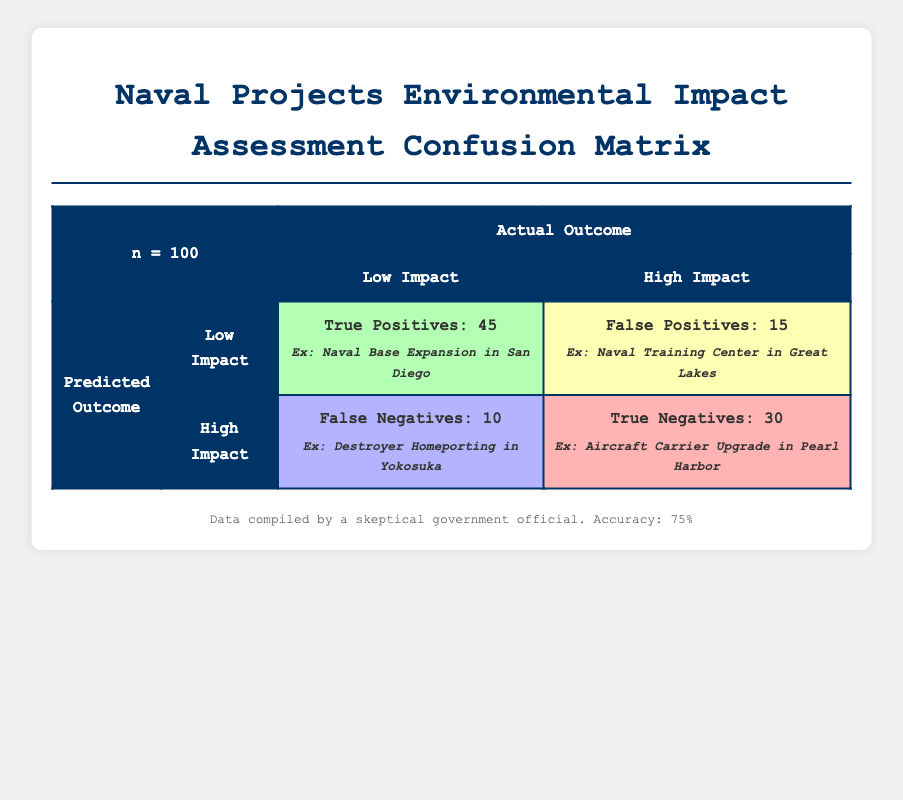What are the total True Positives reported in the assessment? The table indicates that there are 45 True Positives, which represents the projects correctly assessed as having low environmental impact that also truly have a low environmental impact.
Answer: 45 How many assessments inaccurately reported a low environmental impact? The False Positives count is 15, indicating these assessments claimed low environmental impact when the actual impact was high.
Answer: 15 What is the total number of assessments classified as High Environmental Impact? To find the total High Environmental Impact assessments, we add True Negatives (30) and False Negatives (10), giving 30 + 10 = 40.
Answer: 40 What percentage of the assessments were True Positives? To find the percentage, divide the number of True Positives (45) by the total assessments (100) and multiply by 100: (45/100) * 100 = 45%.
Answer: 45% Is it true that more assessments accurately reported Low Environmental Impact than those inaccurately reported as High Environmental Impact? Yes, there are 45 True Positives compared to 10 False Negatives. Thus, the accurate reports exceed the inaccurate ones.
Answer: Yes How many assessments had a correct High Environmental Impact prediction? There are 30 True Negatives, indicating these assessments correctly identified projects as having high environmental impact.
Answer: 30 What is the sum of all Negative assessments? The sum of negative assessments includes True Negatives (30) and False Negatives (10), leading to 30 + 10 = 40.
Answer: 40 How many assessments had the wrong prediction about environmental impact? The sum of False Positives (15) and False Negatives (10) reflects the total incorrect predictions, hence 15 + 10 = 25 incorrect predictions.
Answer: 25 Which project was a False Positive that indicated Low Environmental Impact? The project "Naval Training Center in Great Lakes" reported a low environmental impact but actually had a high environmental impact, making it a False Positive.
Answer: Naval Training Center in Great Lakes What is the ratio of True Positives to False Negatives? The ratio is calculated by comparing True Positives (45) to False Negatives (10). Thus, the ratio is 45:10, which simplifies to 9:2.
Answer: 9:2 